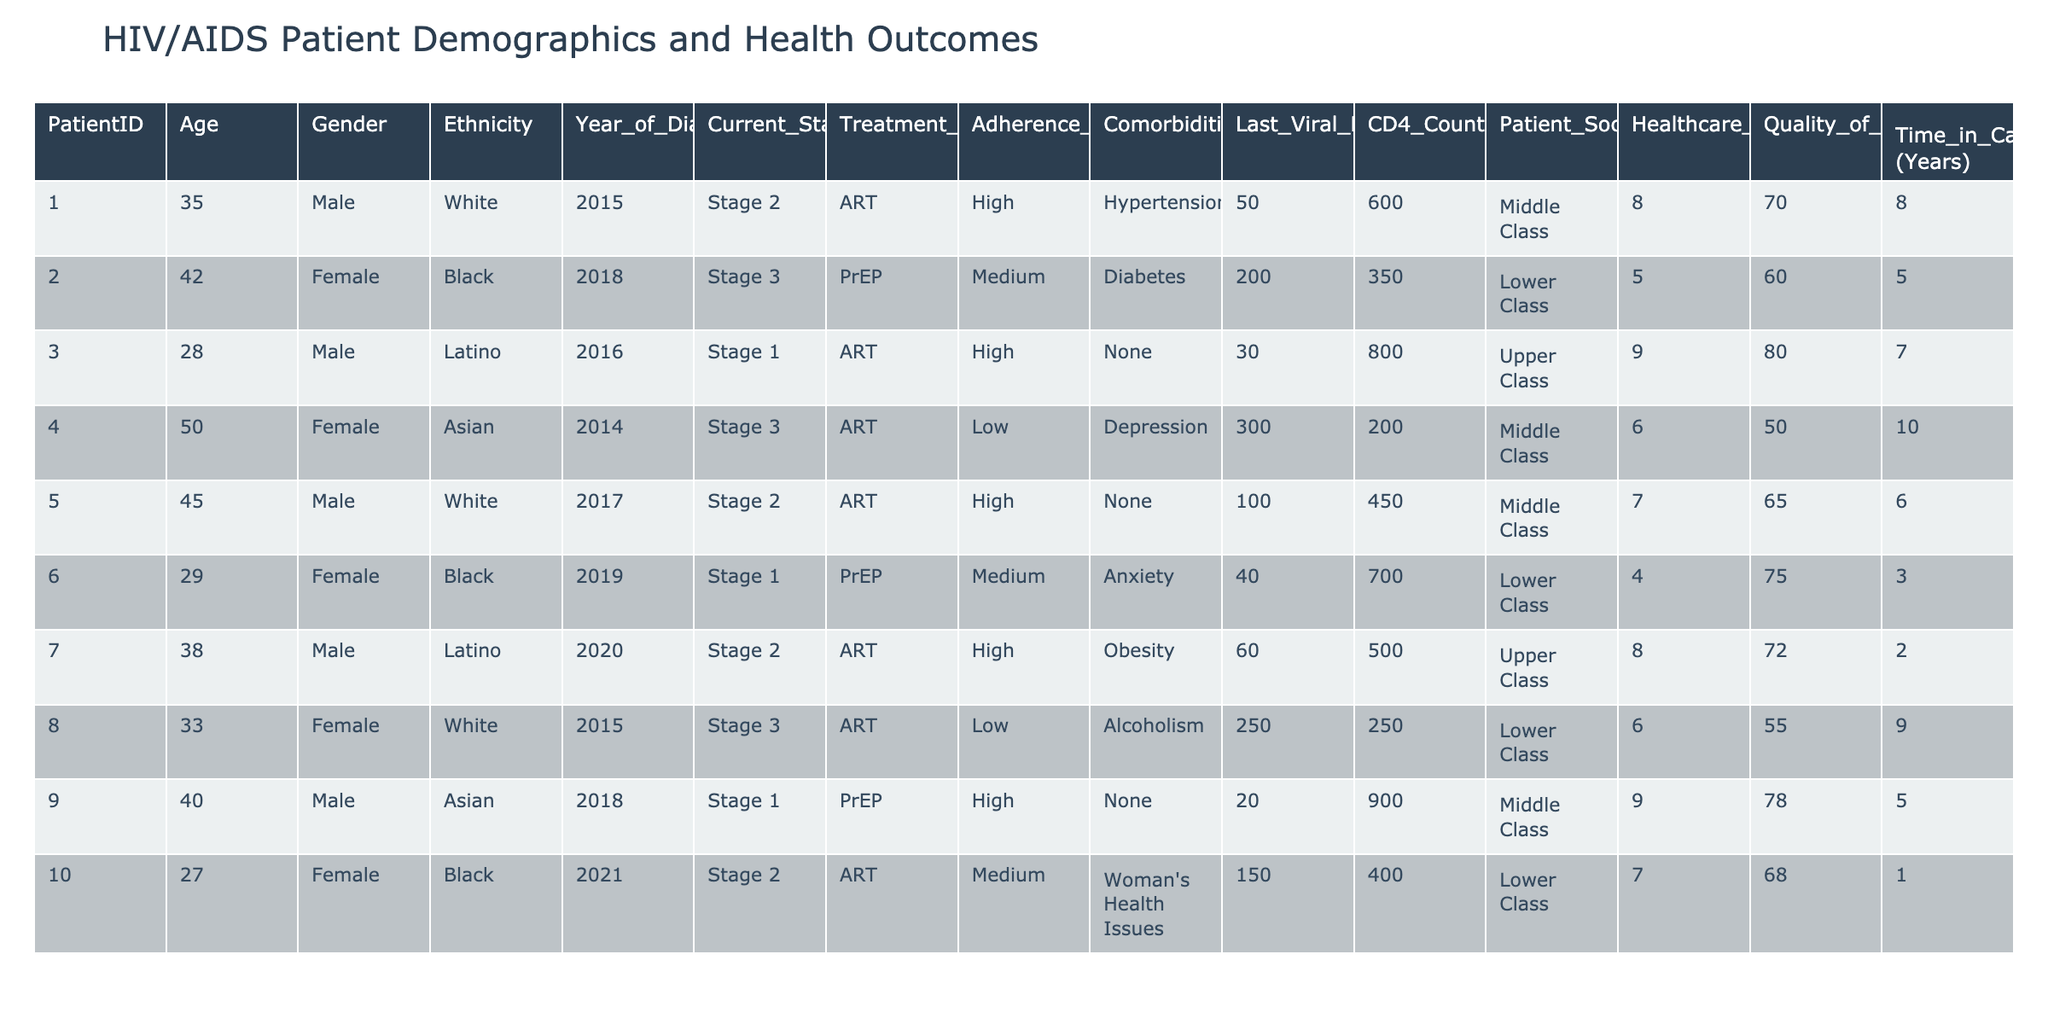What is the age of the oldest patient in the table? The oldest patient listed is PatientID 4, who is 50 years old.
Answer: 50 How many patients are currently in Stage 1 of HIV? There are 4 patients in Stage 1: PatientID 3, 6, 9, and 10.
Answer: 4 What is the adherence level of the patient with the highest CD4 count? PatientID 3 has the highest CD4 count of 800, and their adherence level is High.
Answer: High What is the average CD4 count of patients with a high adherence level? The CD4 counts for high adherence patients (Patients 1, 3, 7, and 9) are 600, 800, 500, and 900, respectively. The average is (600 + 800 + 500 + 900) / 4 = 707.5.
Answer: 707.5 Are there any patients with high socioeconomic status who are in Stage 3? No, all patients in Stage 3 (Patients 2, 4, and 8) come from either Middle or Lower Class socioeconomic statuses.
Answer: No Which gender has the highest average Quality of Life Score? The average Quality of Life Score for males (Patients 1, 3, 5, 7, and 9) is (70 + 80 + 65 + 72 + 78) / 5 = 73; for females (Patients 2, 4, 6, 8, and 10) it is (60 + 50 + 75 + 55 + 68) / 5 = 61.6. Males have a higher average score.
Answer: Male What is the most common treatment type for patients in Stage 2? The treatment type for Stage 2 patients (Patient 1, 5, and 10) is ART for each of them.
Answer: ART How many patients reported comorbidities? The patients with comorbidities are Patient 1 (Hypertension), Patient 2 (Diabetes), Patient 4 (Depression), Patient 6 (Anxiety), Patient 7 (Obesity), and Patient 8 (Alcoholism). In total, 6 patients reported comorbidities.
Answer: 6 What is the relationship between healthcare access score and time in care for patients? Those with higher healthcare access scores (like Patients 1, 3, and 9) also reported longer times in care (8, 7, and 5 years, respectively), indicating a possible positive correlation.
Answer: Positive correlation How many patients aged over 40 are using PrEP? There are no patients over 40 using PrEP. All patients on PrEP (Patients 2, 6, and 10) are 40 or younger.
Answer: 0 